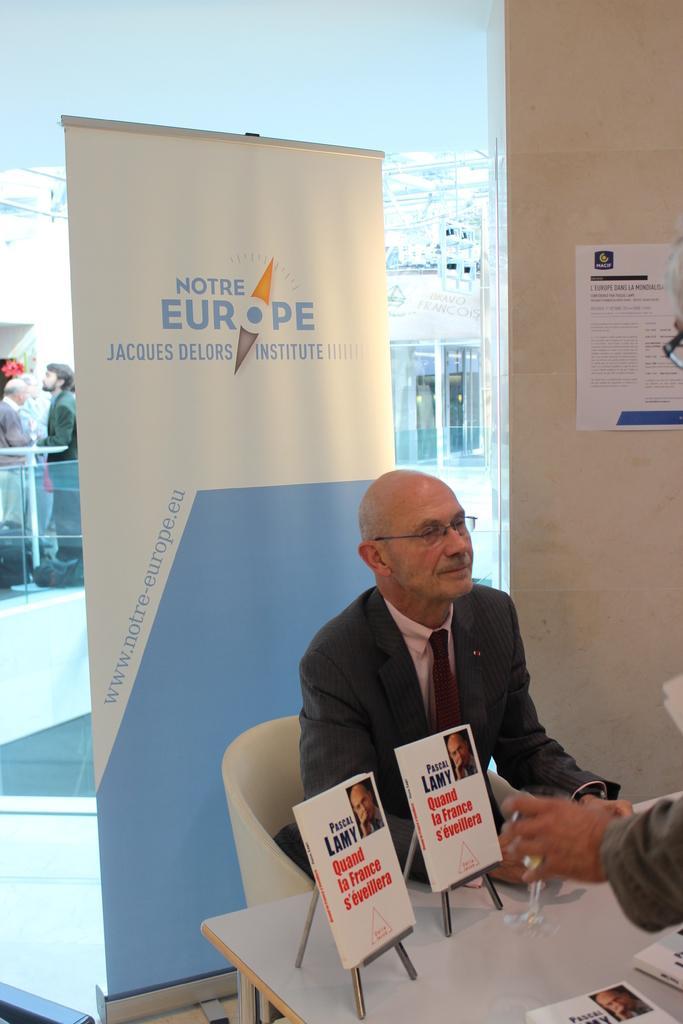Could you give a brief overview of what you see in this image? In this picture I can see a man in front who is sitting on a chair and I see that he is wearing formal dress and I can see a table in front of him on which there are boards and I see something is written on it. On the right side of this picture I can see another man. Behind him I can see the wall, a banner on which there is something written and I can see the glass. Through the glass I can see few people. 